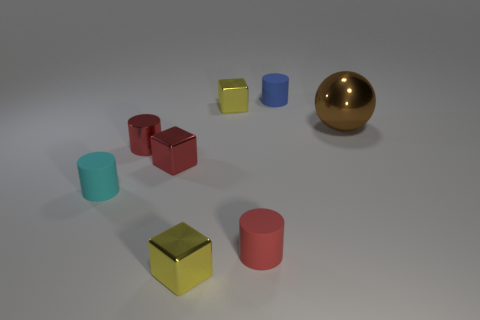Subtract all tiny yellow blocks. How many blocks are left? 1 Add 2 big spheres. How many objects exist? 10 Subtract all red cylinders. How many cylinders are left? 2 Subtract all cyan blocks. How many red cylinders are left? 2 Subtract all blocks. How many objects are left? 5 Subtract 0 cyan spheres. How many objects are left? 8 Subtract 1 blocks. How many blocks are left? 2 Subtract all red spheres. Subtract all red cubes. How many spheres are left? 1 Subtract all cyan rubber objects. Subtract all cyan rubber objects. How many objects are left? 6 Add 4 red blocks. How many red blocks are left? 5 